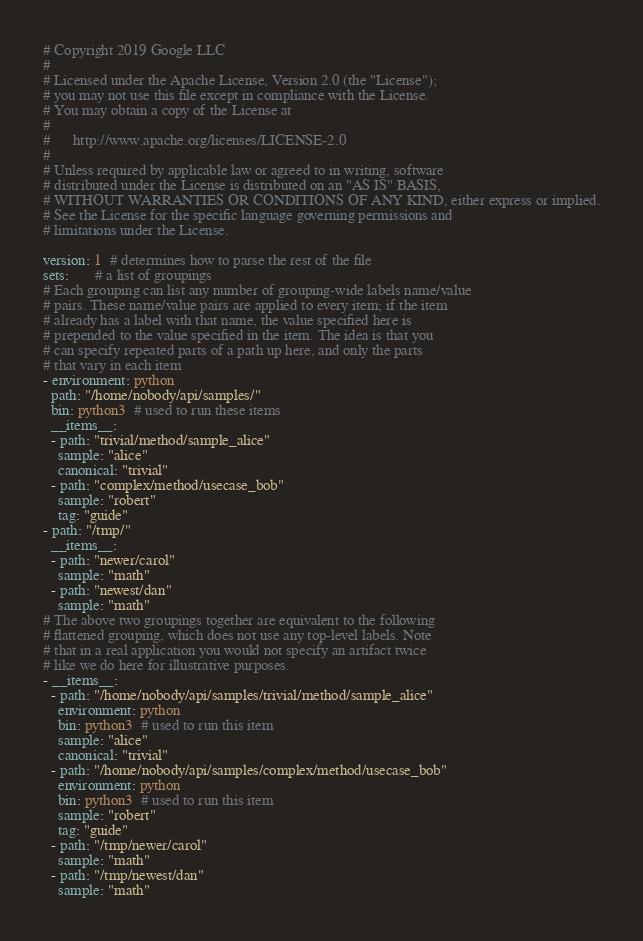Convert code to text. <code><loc_0><loc_0><loc_500><loc_500><_YAML_># Copyright 2019 Google LLC
#
# Licensed under the Apache License, Version 2.0 (the "License");
# you may not use this file except in compliance with the License.
# You may obtain a copy of the License at
#
#      http://www.apache.org/licenses/LICENSE-2.0
#
# Unless required by applicable law or agreed to in writing, software
# distributed under the License is distributed on an "AS IS" BASIS,
# WITHOUT WARRANTIES OR CONDITIONS OF ANY KIND, either express or implied.
# See the License for the specific language governing permissions and
# limitations under the License.

version: 1  # determines how to parse the rest of the file
sets:       # a list of groupings
# Each grouping can list any number of grouping-wide labels name/value
# pairs. These name/value pairs are applied to every item; if the item
# already has a label with that name, the value specified here is
# prepended to the value specified in the item. The idea is that you
# can specify repeated parts of a path up here, and only the parts
# that vary in each item
- environment: python
  path: "/home/nobody/api/samples/"
  bin: python3  # used to run these items
  __items__:
  - path: "trivial/method/sample_alice"
    sample: "alice"
    canonical: "trivial"
  - path: "complex/method/usecase_bob"
    sample: "robert"
    tag: "guide"
- path: "/tmp/"
  __items__:
  - path: "newer/carol"
    sample: "math"
  - path: "newest/dan"
    sample: "math"
# The above two groupings together are equivalent to the following
# flattened grouping, which does not use any top-level labels. Note
# that in a real application you would not specify an artifact twice
# like we do here for illustrative purposes.
- __items__:
  - path: "/home/nobody/api/samples/trivial/method/sample_alice"
    environment: python
    bin: python3  # used to run this item
    sample: "alice"
    canonical: "trivial"
  - path: "/home/nobody/api/samples/complex/method/usecase_bob"
    environment: python
    bin: python3  # used to run this item
    sample: "robert"
    tag: "guide"
  - path: "/tmp/newer/carol"
    sample: "math"
  - path: "/tmp/newest/dan"
    sample: "math"
</code> 